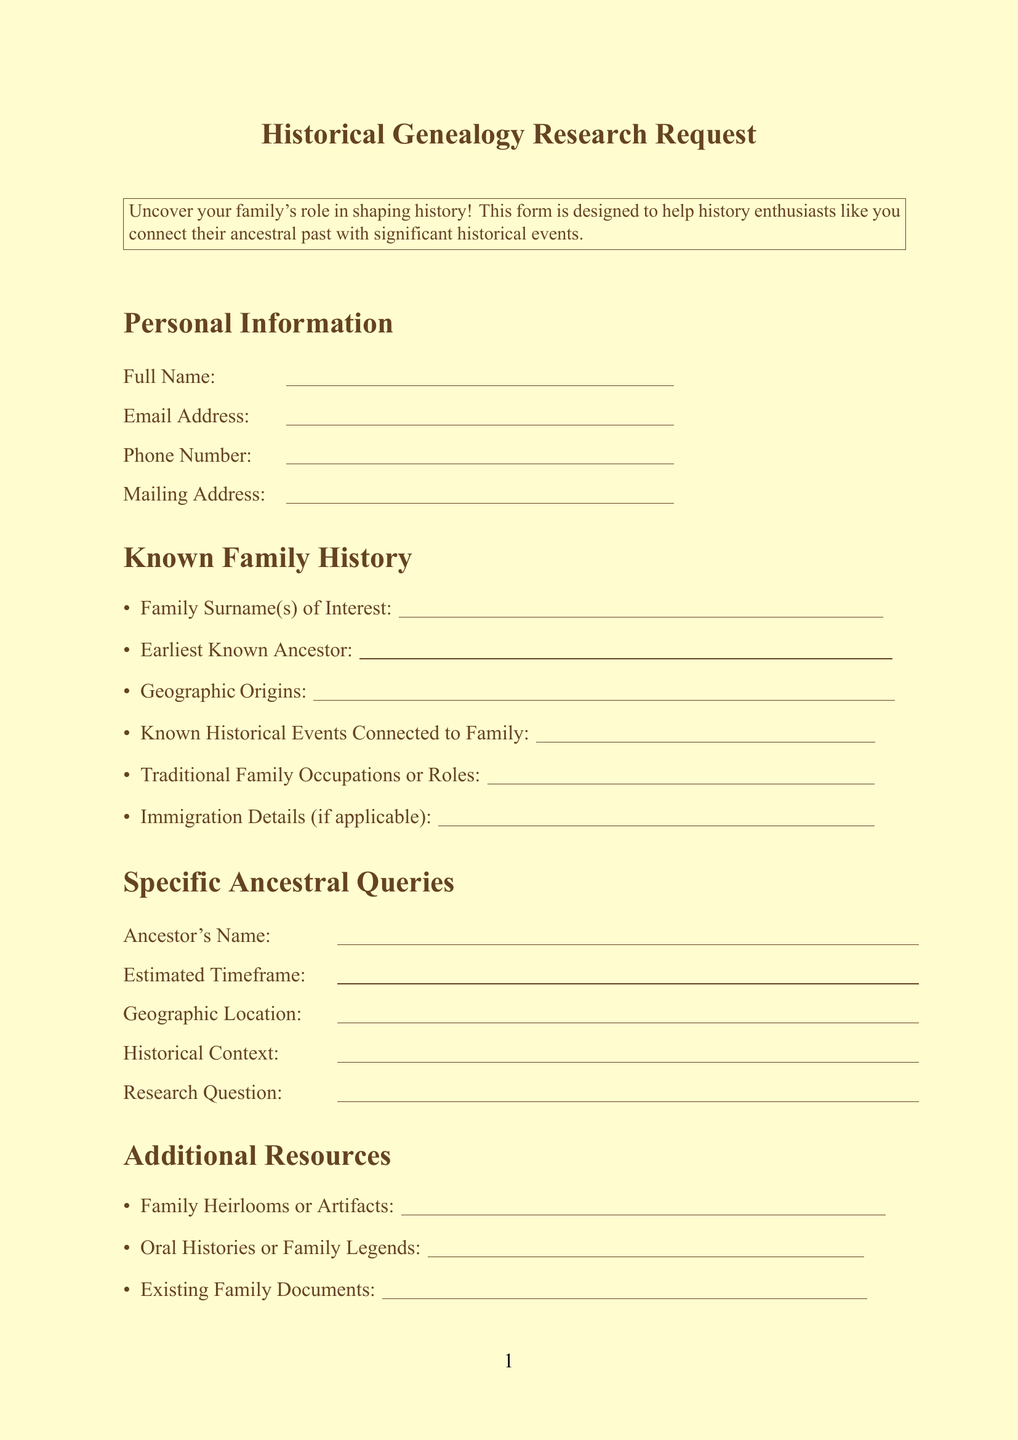What is the title of the form? The title is prominently displayed at the top of the document, which outlines the focus of the request.
Answer: Historical Genealogy Research Request What is the introductory text? The introduction provides context for why the form is designed and who it is for.
Answer: Uncover your family's role in shaping history! This form is designed to help history enthusiasts like you connect their ancestral past with significant historical events What information is required in the personal information section? The personal information section lists specific details that need to be provided by the applicant.
Answer: Full Name, Email Address, Phone Number, Mailing Address What should be included about the earliest known ancestor? This part of the form asks for specific details about the ancestor which is essential for the research.
Answer: Earliest Known Ancestor (Name and approximate dates) What are preferred sources for research? This section lists various types of sources that the applicant can choose from which may assist in their genealogical research.
Answer: Census Records, Church Records, Military Records, Newspaper Archives, DNA Testing, Academic Historical Journals How does the document address confidentiality? The form includes a statement regarding the willingness of the applicant to understand and approach their family's past critically.
Answer: I understand that genealogical research may uncover unexpected historical connections and am prepared to critically examine my family's role in past events What is one of the sections related to historical interests? This section seeks to identify the applicant's specific interests which can guide the research focus.
Answer: Historical Periods of Particular Interest What kind of additional information can be provided in the comments section? Here, applicants can express any extra information that may aid their research or special requests concerning the form.
Answer: Any Additional Information or Special Requests What is a core requirement for signing the form? This is the confirmation aspect of the form where the applicant indicates their validation of the information provided.
Answer: Signature 